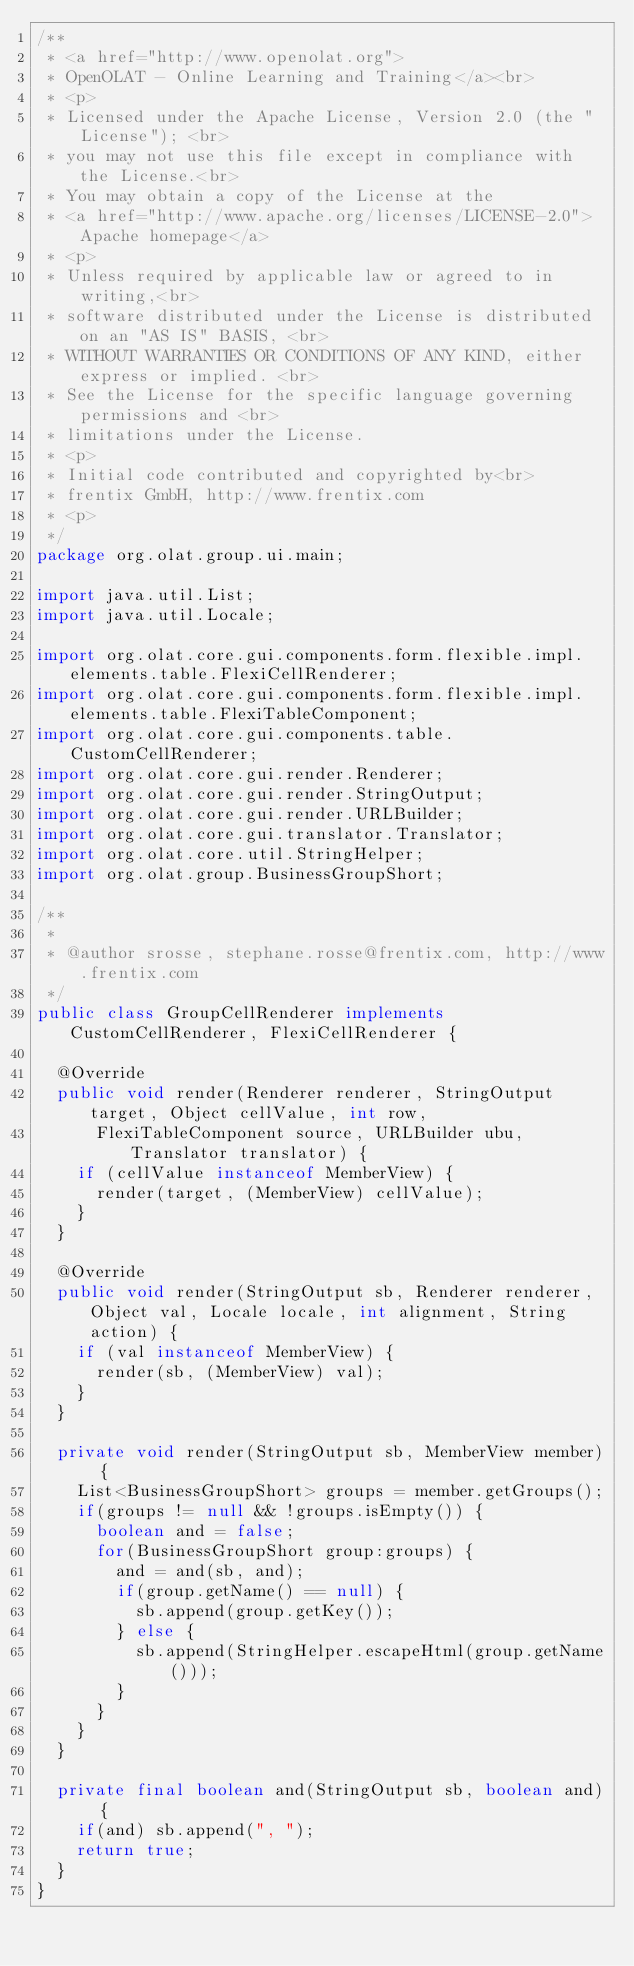Convert code to text. <code><loc_0><loc_0><loc_500><loc_500><_Java_>/**
 * <a href="http://www.openolat.org">
 * OpenOLAT - Online Learning and Training</a><br>
 * <p>
 * Licensed under the Apache License, Version 2.0 (the "License"); <br>
 * you may not use this file except in compliance with the License.<br>
 * You may obtain a copy of the License at the
 * <a href="http://www.apache.org/licenses/LICENSE-2.0">Apache homepage</a>
 * <p>
 * Unless required by applicable law or agreed to in writing,<br>
 * software distributed under the License is distributed on an "AS IS" BASIS, <br>
 * WITHOUT WARRANTIES OR CONDITIONS OF ANY KIND, either express or implied. <br>
 * See the License for the specific language governing permissions and <br>
 * limitations under the License.
 * <p>
 * Initial code contributed and copyrighted by<br>
 * frentix GmbH, http://www.frentix.com
 * <p>
 */
package org.olat.group.ui.main;

import java.util.List;
import java.util.Locale;

import org.olat.core.gui.components.form.flexible.impl.elements.table.FlexiCellRenderer;
import org.olat.core.gui.components.form.flexible.impl.elements.table.FlexiTableComponent;
import org.olat.core.gui.components.table.CustomCellRenderer;
import org.olat.core.gui.render.Renderer;
import org.olat.core.gui.render.StringOutput;
import org.olat.core.gui.render.URLBuilder;
import org.olat.core.gui.translator.Translator;
import org.olat.core.util.StringHelper;
import org.olat.group.BusinessGroupShort;

/**
 * 
 * @author srosse, stephane.rosse@frentix.com, http://www.frentix.com
 */
public class GroupCellRenderer implements CustomCellRenderer, FlexiCellRenderer {

	@Override
	public void render(Renderer renderer, StringOutput target, Object cellValue, int row,
			FlexiTableComponent source, URLBuilder ubu, Translator translator) {
		if (cellValue instanceof MemberView) {
			render(target, (MemberView) cellValue);
		}
	}

	@Override
	public void render(StringOutput sb, Renderer renderer, Object val, Locale locale, int alignment, String action) {
		if (val instanceof MemberView) {
			render(sb, (MemberView) val);
		}
	}
	
	private void render(StringOutput sb, MemberView member) {
		List<BusinessGroupShort> groups = member.getGroups();
		if(groups != null && !groups.isEmpty()) {
			boolean and = false;
			for(BusinessGroupShort group:groups) {
				and = and(sb, and);
				if(group.getName() == null) {
					sb.append(group.getKey());
				} else {
					sb.append(StringHelper.escapeHtml(group.getName()));
				}
			}
		}
	}
	
	private final boolean and(StringOutput sb, boolean and) {
		if(and) sb.append(", ");
		return true;
	}
}
</code> 